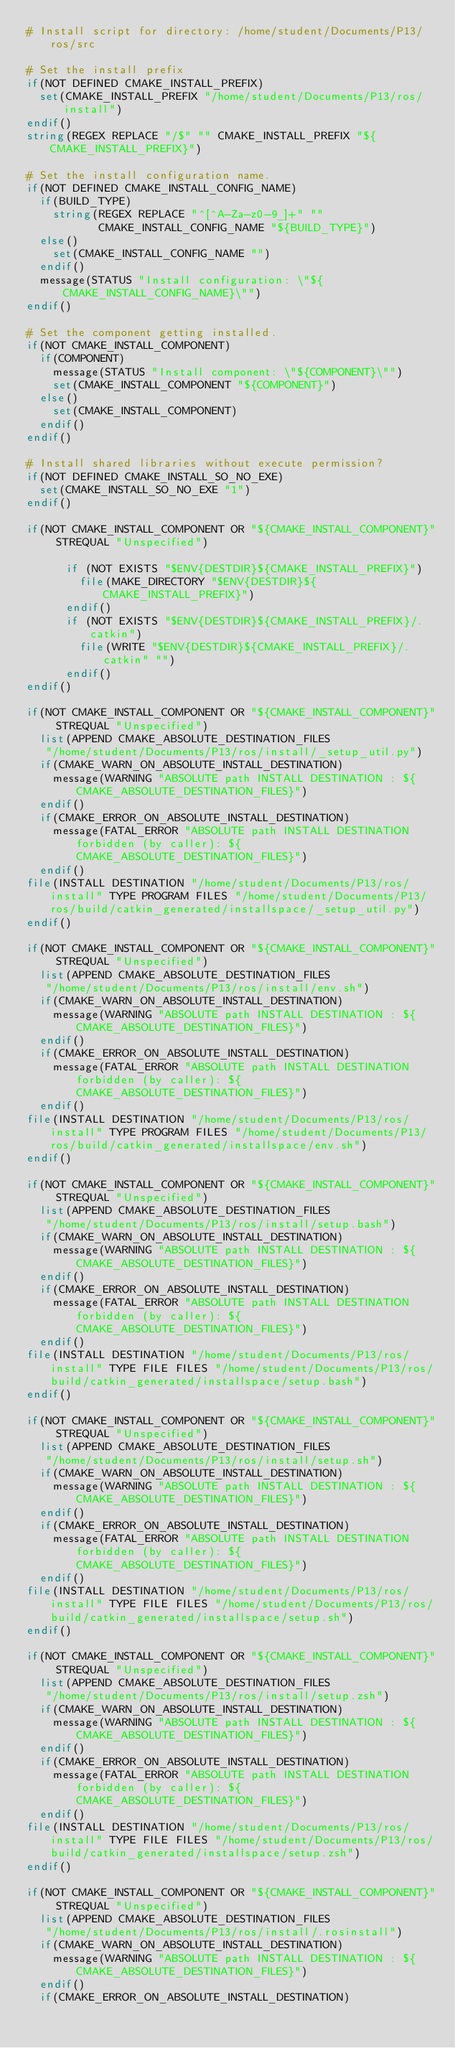<code> <loc_0><loc_0><loc_500><loc_500><_CMake_># Install script for directory: /home/student/Documents/P13/ros/src

# Set the install prefix
if(NOT DEFINED CMAKE_INSTALL_PREFIX)
  set(CMAKE_INSTALL_PREFIX "/home/student/Documents/P13/ros/install")
endif()
string(REGEX REPLACE "/$" "" CMAKE_INSTALL_PREFIX "${CMAKE_INSTALL_PREFIX}")

# Set the install configuration name.
if(NOT DEFINED CMAKE_INSTALL_CONFIG_NAME)
  if(BUILD_TYPE)
    string(REGEX REPLACE "^[^A-Za-z0-9_]+" ""
           CMAKE_INSTALL_CONFIG_NAME "${BUILD_TYPE}")
  else()
    set(CMAKE_INSTALL_CONFIG_NAME "")
  endif()
  message(STATUS "Install configuration: \"${CMAKE_INSTALL_CONFIG_NAME}\"")
endif()

# Set the component getting installed.
if(NOT CMAKE_INSTALL_COMPONENT)
  if(COMPONENT)
    message(STATUS "Install component: \"${COMPONENT}\"")
    set(CMAKE_INSTALL_COMPONENT "${COMPONENT}")
  else()
    set(CMAKE_INSTALL_COMPONENT)
  endif()
endif()

# Install shared libraries without execute permission?
if(NOT DEFINED CMAKE_INSTALL_SO_NO_EXE)
  set(CMAKE_INSTALL_SO_NO_EXE "1")
endif()

if(NOT CMAKE_INSTALL_COMPONENT OR "${CMAKE_INSTALL_COMPONENT}" STREQUAL "Unspecified")
  
      if (NOT EXISTS "$ENV{DESTDIR}${CMAKE_INSTALL_PREFIX}")
        file(MAKE_DIRECTORY "$ENV{DESTDIR}${CMAKE_INSTALL_PREFIX}")
      endif()
      if (NOT EXISTS "$ENV{DESTDIR}${CMAKE_INSTALL_PREFIX}/.catkin")
        file(WRITE "$ENV{DESTDIR}${CMAKE_INSTALL_PREFIX}/.catkin" "")
      endif()
endif()

if(NOT CMAKE_INSTALL_COMPONENT OR "${CMAKE_INSTALL_COMPONENT}" STREQUAL "Unspecified")
  list(APPEND CMAKE_ABSOLUTE_DESTINATION_FILES
   "/home/student/Documents/P13/ros/install/_setup_util.py")
  if(CMAKE_WARN_ON_ABSOLUTE_INSTALL_DESTINATION)
    message(WARNING "ABSOLUTE path INSTALL DESTINATION : ${CMAKE_ABSOLUTE_DESTINATION_FILES}")
  endif()
  if(CMAKE_ERROR_ON_ABSOLUTE_INSTALL_DESTINATION)
    message(FATAL_ERROR "ABSOLUTE path INSTALL DESTINATION forbidden (by caller): ${CMAKE_ABSOLUTE_DESTINATION_FILES}")
  endif()
file(INSTALL DESTINATION "/home/student/Documents/P13/ros/install" TYPE PROGRAM FILES "/home/student/Documents/P13/ros/build/catkin_generated/installspace/_setup_util.py")
endif()

if(NOT CMAKE_INSTALL_COMPONENT OR "${CMAKE_INSTALL_COMPONENT}" STREQUAL "Unspecified")
  list(APPEND CMAKE_ABSOLUTE_DESTINATION_FILES
   "/home/student/Documents/P13/ros/install/env.sh")
  if(CMAKE_WARN_ON_ABSOLUTE_INSTALL_DESTINATION)
    message(WARNING "ABSOLUTE path INSTALL DESTINATION : ${CMAKE_ABSOLUTE_DESTINATION_FILES}")
  endif()
  if(CMAKE_ERROR_ON_ABSOLUTE_INSTALL_DESTINATION)
    message(FATAL_ERROR "ABSOLUTE path INSTALL DESTINATION forbidden (by caller): ${CMAKE_ABSOLUTE_DESTINATION_FILES}")
  endif()
file(INSTALL DESTINATION "/home/student/Documents/P13/ros/install" TYPE PROGRAM FILES "/home/student/Documents/P13/ros/build/catkin_generated/installspace/env.sh")
endif()

if(NOT CMAKE_INSTALL_COMPONENT OR "${CMAKE_INSTALL_COMPONENT}" STREQUAL "Unspecified")
  list(APPEND CMAKE_ABSOLUTE_DESTINATION_FILES
   "/home/student/Documents/P13/ros/install/setup.bash")
  if(CMAKE_WARN_ON_ABSOLUTE_INSTALL_DESTINATION)
    message(WARNING "ABSOLUTE path INSTALL DESTINATION : ${CMAKE_ABSOLUTE_DESTINATION_FILES}")
  endif()
  if(CMAKE_ERROR_ON_ABSOLUTE_INSTALL_DESTINATION)
    message(FATAL_ERROR "ABSOLUTE path INSTALL DESTINATION forbidden (by caller): ${CMAKE_ABSOLUTE_DESTINATION_FILES}")
  endif()
file(INSTALL DESTINATION "/home/student/Documents/P13/ros/install" TYPE FILE FILES "/home/student/Documents/P13/ros/build/catkin_generated/installspace/setup.bash")
endif()

if(NOT CMAKE_INSTALL_COMPONENT OR "${CMAKE_INSTALL_COMPONENT}" STREQUAL "Unspecified")
  list(APPEND CMAKE_ABSOLUTE_DESTINATION_FILES
   "/home/student/Documents/P13/ros/install/setup.sh")
  if(CMAKE_WARN_ON_ABSOLUTE_INSTALL_DESTINATION)
    message(WARNING "ABSOLUTE path INSTALL DESTINATION : ${CMAKE_ABSOLUTE_DESTINATION_FILES}")
  endif()
  if(CMAKE_ERROR_ON_ABSOLUTE_INSTALL_DESTINATION)
    message(FATAL_ERROR "ABSOLUTE path INSTALL DESTINATION forbidden (by caller): ${CMAKE_ABSOLUTE_DESTINATION_FILES}")
  endif()
file(INSTALL DESTINATION "/home/student/Documents/P13/ros/install" TYPE FILE FILES "/home/student/Documents/P13/ros/build/catkin_generated/installspace/setup.sh")
endif()

if(NOT CMAKE_INSTALL_COMPONENT OR "${CMAKE_INSTALL_COMPONENT}" STREQUAL "Unspecified")
  list(APPEND CMAKE_ABSOLUTE_DESTINATION_FILES
   "/home/student/Documents/P13/ros/install/setup.zsh")
  if(CMAKE_WARN_ON_ABSOLUTE_INSTALL_DESTINATION)
    message(WARNING "ABSOLUTE path INSTALL DESTINATION : ${CMAKE_ABSOLUTE_DESTINATION_FILES}")
  endif()
  if(CMAKE_ERROR_ON_ABSOLUTE_INSTALL_DESTINATION)
    message(FATAL_ERROR "ABSOLUTE path INSTALL DESTINATION forbidden (by caller): ${CMAKE_ABSOLUTE_DESTINATION_FILES}")
  endif()
file(INSTALL DESTINATION "/home/student/Documents/P13/ros/install" TYPE FILE FILES "/home/student/Documents/P13/ros/build/catkin_generated/installspace/setup.zsh")
endif()

if(NOT CMAKE_INSTALL_COMPONENT OR "${CMAKE_INSTALL_COMPONENT}" STREQUAL "Unspecified")
  list(APPEND CMAKE_ABSOLUTE_DESTINATION_FILES
   "/home/student/Documents/P13/ros/install/.rosinstall")
  if(CMAKE_WARN_ON_ABSOLUTE_INSTALL_DESTINATION)
    message(WARNING "ABSOLUTE path INSTALL DESTINATION : ${CMAKE_ABSOLUTE_DESTINATION_FILES}")
  endif()
  if(CMAKE_ERROR_ON_ABSOLUTE_INSTALL_DESTINATION)</code> 